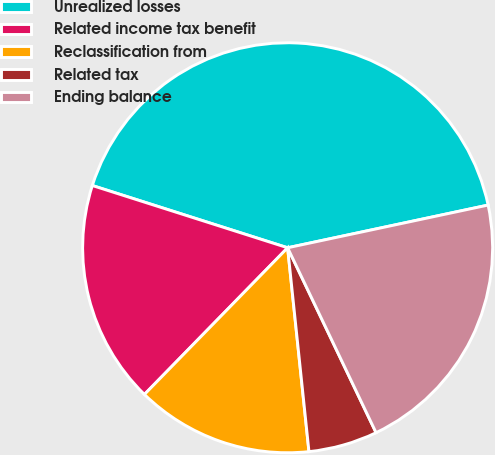<chart> <loc_0><loc_0><loc_500><loc_500><pie_chart><fcel>Unrealized losses<fcel>Related income tax benefit<fcel>Reclassification from<fcel>Related tax<fcel>Ending balance<nl><fcel>41.75%<fcel>17.6%<fcel>13.97%<fcel>5.44%<fcel>21.24%<nl></chart> 